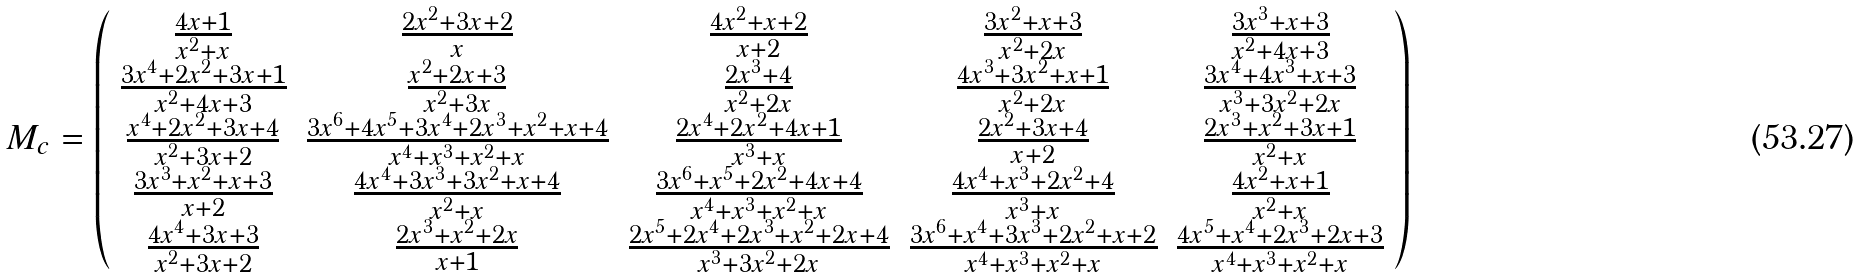<formula> <loc_0><loc_0><loc_500><loc_500>M _ { c } = \left ( \begin{array} { c c c c c } \frac { 4 x + 1 } { x ^ { 2 } + x } & \frac { 2 x ^ { 2 } + 3 x + 2 } x & \frac { 4 x ^ { 2 } + x + 2 } { x + 2 } & \frac { 3 x ^ { 2 } + x + 3 } { x ^ { 2 } + 2 x } & \frac { 3 x ^ { 3 } + x + 3 } { x ^ { 2 } + 4 x + 3 } \\ \frac { 3 x ^ { 4 } + 2 x ^ { 2 } + 3 x + 1 } { x ^ { 2 } + 4 x + 3 } & \frac { x ^ { 2 } + 2 x + 3 } { x ^ { 2 } + 3 x } & \frac { 2 x ^ { 3 } + 4 } { x ^ { 2 } + 2 x } & \frac { 4 x ^ { 3 } + 3 x ^ { 2 } + x + 1 } { x ^ { 2 } + 2 x } & \frac { 3 x ^ { 4 } + 4 x ^ { 3 } + x + 3 } { x ^ { 3 } + 3 x ^ { 2 } + 2 x } \\ \frac { x ^ { 4 } + 2 x ^ { 2 } + 3 x + 4 } { x ^ { 2 } + 3 x + 2 } & \frac { 3 x ^ { 6 } + 4 x ^ { 5 } + 3 x ^ { 4 } + 2 x ^ { 3 } + x ^ { 2 } + x + 4 } { x ^ { 4 } + x ^ { 3 } + x ^ { 2 } + x } & \frac { 2 x ^ { 4 } + 2 x ^ { 2 } + 4 x + 1 } { x ^ { 3 } + x } & \frac { 2 x ^ { 2 } + 3 x + 4 } { x + 2 } & \frac { 2 x ^ { 3 } + x ^ { 2 } + 3 x + 1 } { x ^ { 2 } + x } \\ \frac { 3 x ^ { 3 } + x ^ { 2 } + x + 3 } { x + 2 } & \frac { 4 x ^ { 4 } + 3 x ^ { 3 } + 3 x ^ { 2 } + x + 4 } { x ^ { 2 } + x } & \frac { 3 x ^ { 6 } + x ^ { 5 } + 2 x ^ { 2 } + 4 x + 4 } { x ^ { 4 } + x ^ { 3 } + x ^ { 2 } + x } & \frac { 4 x ^ { 4 } + x ^ { 3 } + 2 x ^ { 2 } + 4 } { x ^ { 3 } + x } & \frac { 4 x ^ { 2 } + x + 1 } { x ^ { 2 } + x } \\ \frac { 4 x ^ { 4 } + 3 x + 3 } { x ^ { 2 } + 3 x + 2 } & \frac { 2 x ^ { 3 } + x ^ { 2 } + 2 x } { x + 1 } & \frac { 2 x ^ { 5 } + 2 x ^ { 4 } + 2 x ^ { 3 } + x ^ { 2 } + 2 x + 4 } { x ^ { 3 } + 3 x ^ { 2 } + 2 x } & \frac { 3 x ^ { 6 } + x ^ { 4 } + 3 x ^ { 3 } + 2 x ^ { 2 } + x + 2 } { x ^ { 4 } + x ^ { 3 } + x ^ { 2 } + x } & \frac { 4 x ^ { 5 } + x ^ { 4 } + 2 x ^ { 3 } + 2 x + 3 } { x ^ { 4 } + x ^ { 3 } + x ^ { 2 } + x } \end{array} \right )</formula> 